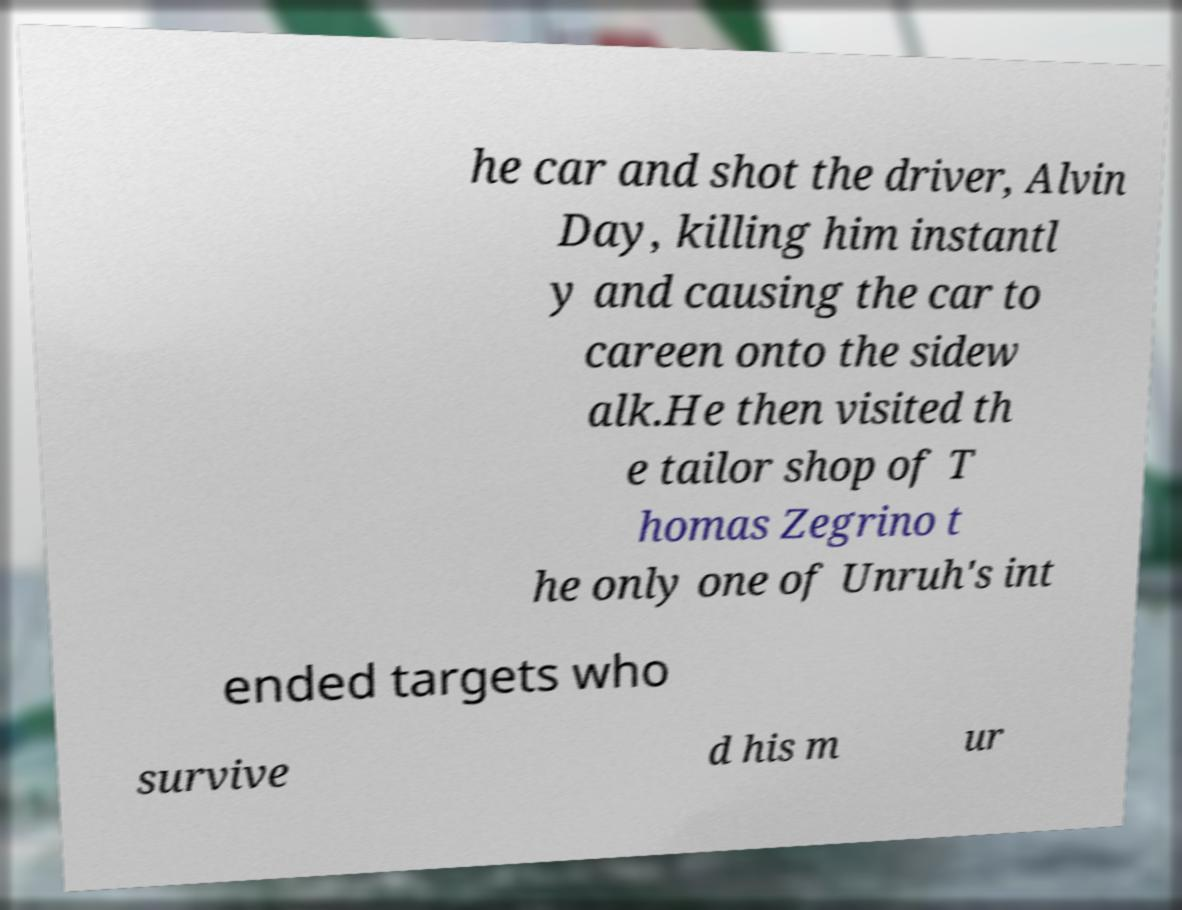Please read and relay the text visible in this image. What does it say? he car and shot the driver, Alvin Day, killing him instantl y and causing the car to careen onto the sidew alk.He then visited th e tailor shop of T homas Zegrino t he only one of Unruh's int ended targets who survive d his m ur 